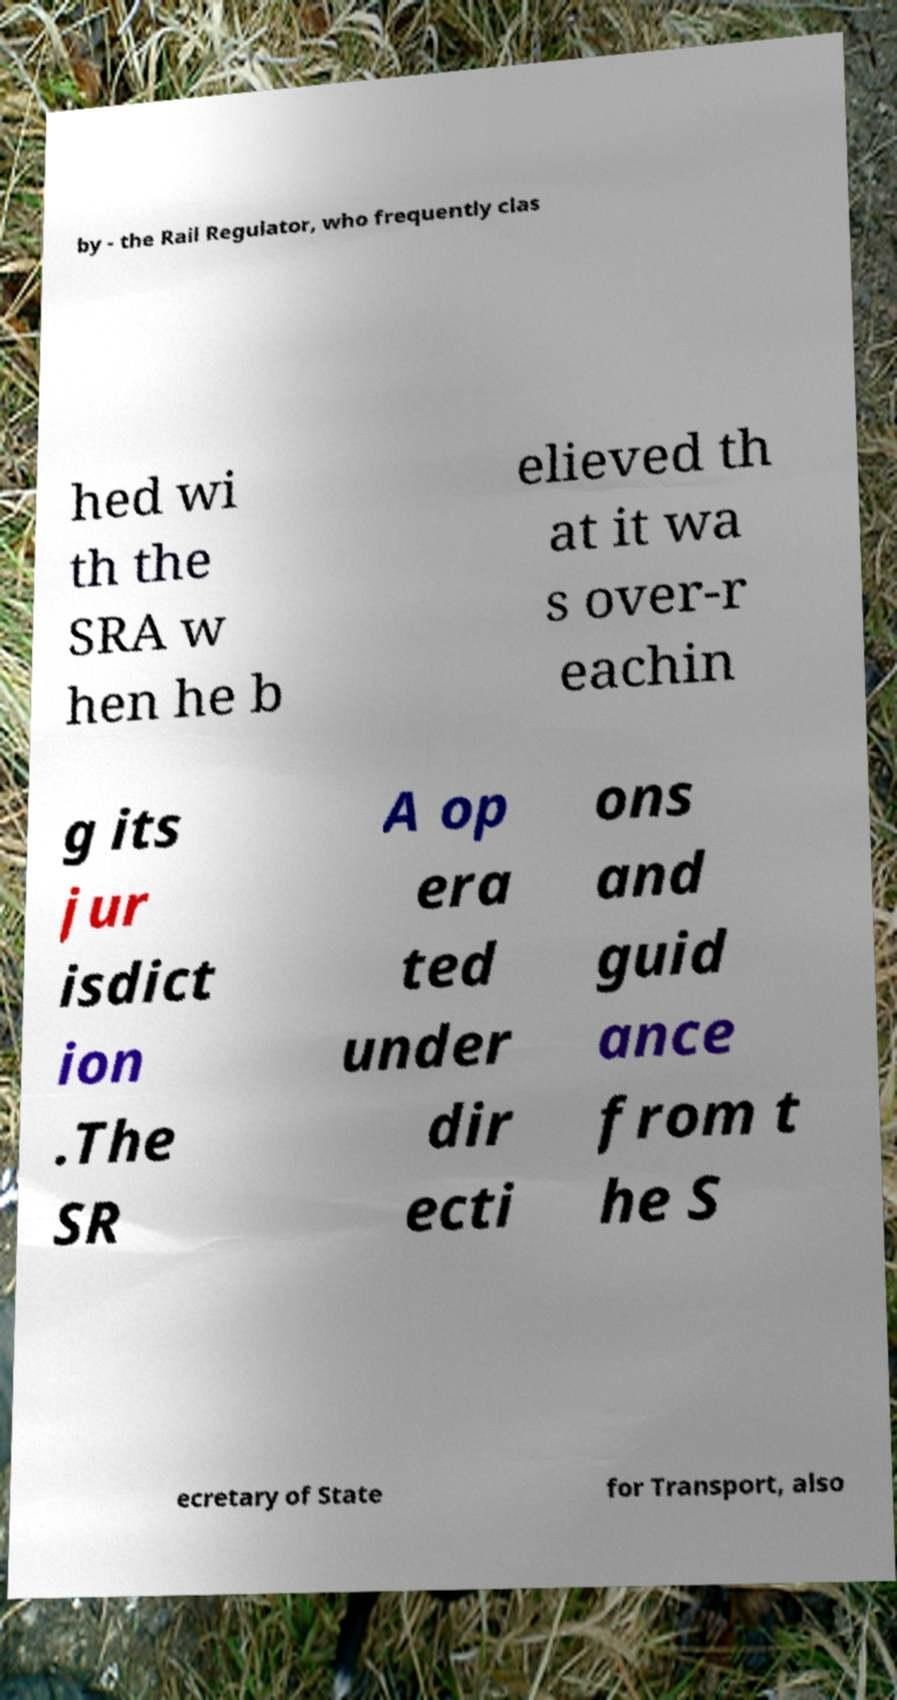There's text embedded in this image that I need extracted. Can you transcribe it verbatim? by - the Rail Regulator, who frequently clas hed wi th the SRA w hen he b elieved th at it wa s over-r eachin g its jur isdict ion .The SR A op era ted under dir ecti ons and guid ance from t he S ecretary of State for Transport, also 